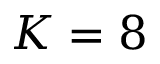<formula> <loc_0><loc_0><loc_500><loc_500>K = 8</formula> 